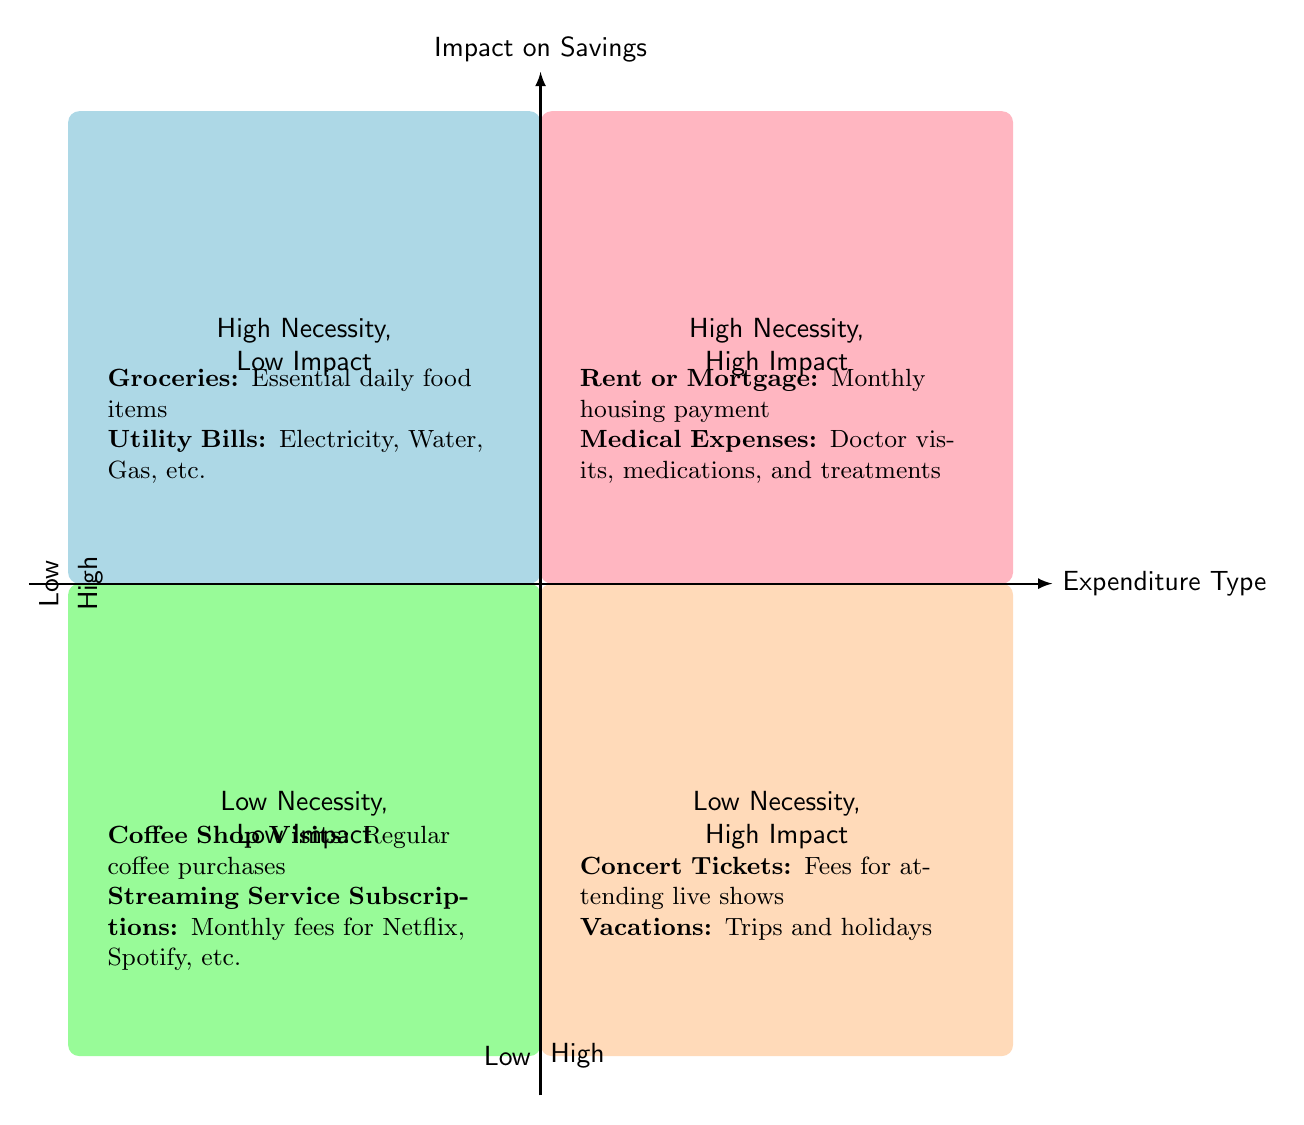What's in quadrant Q1? Quadrant Q1 represents "High Necessity, Low Impact". The items listed in this quadrant are Groceries and Utility Bills.
Answer: Groceries, Utility Bills Which expenditure in Q2 has variable costs? In quadrant Q2, the expenditure that has variable costs is Medical Expenses. This is explicitly stated in the quadrant's description.
Answer: Medical Expenses How many expenditures fall under "Low Necessity, Low Impact"? Quadrant Q3 lists two expenditures: Coffee Shop Visits and Streaming Service Subscriptions. Therefore, the total number of expenditures in this quadrant is two.
Answer: 2 In which quadrant would you categorize Concert Tickets? Concert Tickets are classified in quadrant Q4, which is labeled "Low Necessity, High Impact". This is based on its provided category and description in the diagram.
Answer: Q4 Name an essential item from quadrant Q1. An essential item listed in quadrant Q1 is Groceries. This is identified as a necessity in the context of the quadrant.
Answer: Groceries Which quadrant has the highest-cost items? Quadrant Q2, labeled "High Necessity, High Impact", contains items like Rent or Mortgage and Medical Expenses, both of which have high or variable costs, indicating this quadrant handles the highest-cost items.
Answer: Q2 What is the overall theme of the expenditures in Q4? The overall theme of Q4 is that the expenditures listed (Concert Tickets and Vacations) are categorized as non-essential or luxury items that have a high impact on savings.
Answer: Non-essential luxury items How are the items in Q3 primarily categorized? The items in Q3—Coffee Shop Visits and Streaming Service Subscriptions—are primarily categorized as Low Necessity and Low Impact, highlighting that they are not critical to financial wellbeing.
Answer: Low Necessity, Low Impact 